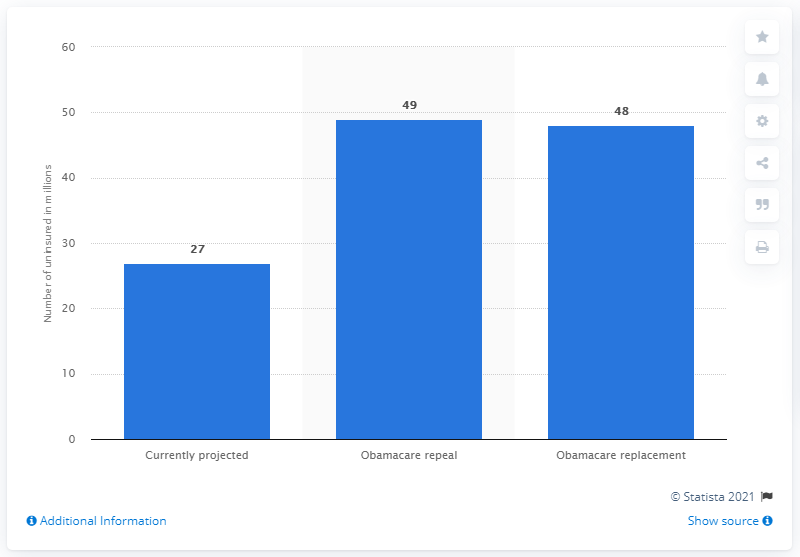Indicate a few pertinent items in this graphic. It is estimated that if the Affordable Care Act were to be repealed, approximately 49 million people would become uninsured. If the Affordable Care Act were to be repealed, an estimated 27 million people would become uninsured. 